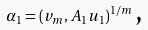Convert formula to latex. <formula><loc_0><loc_0><loc_500><loc_500>\alpha _ { 1 } = \left ( v _ { m } , A _ { 1 } u _ { 1 } \right ) ^ { 1 / m } \text {,}</formula> 